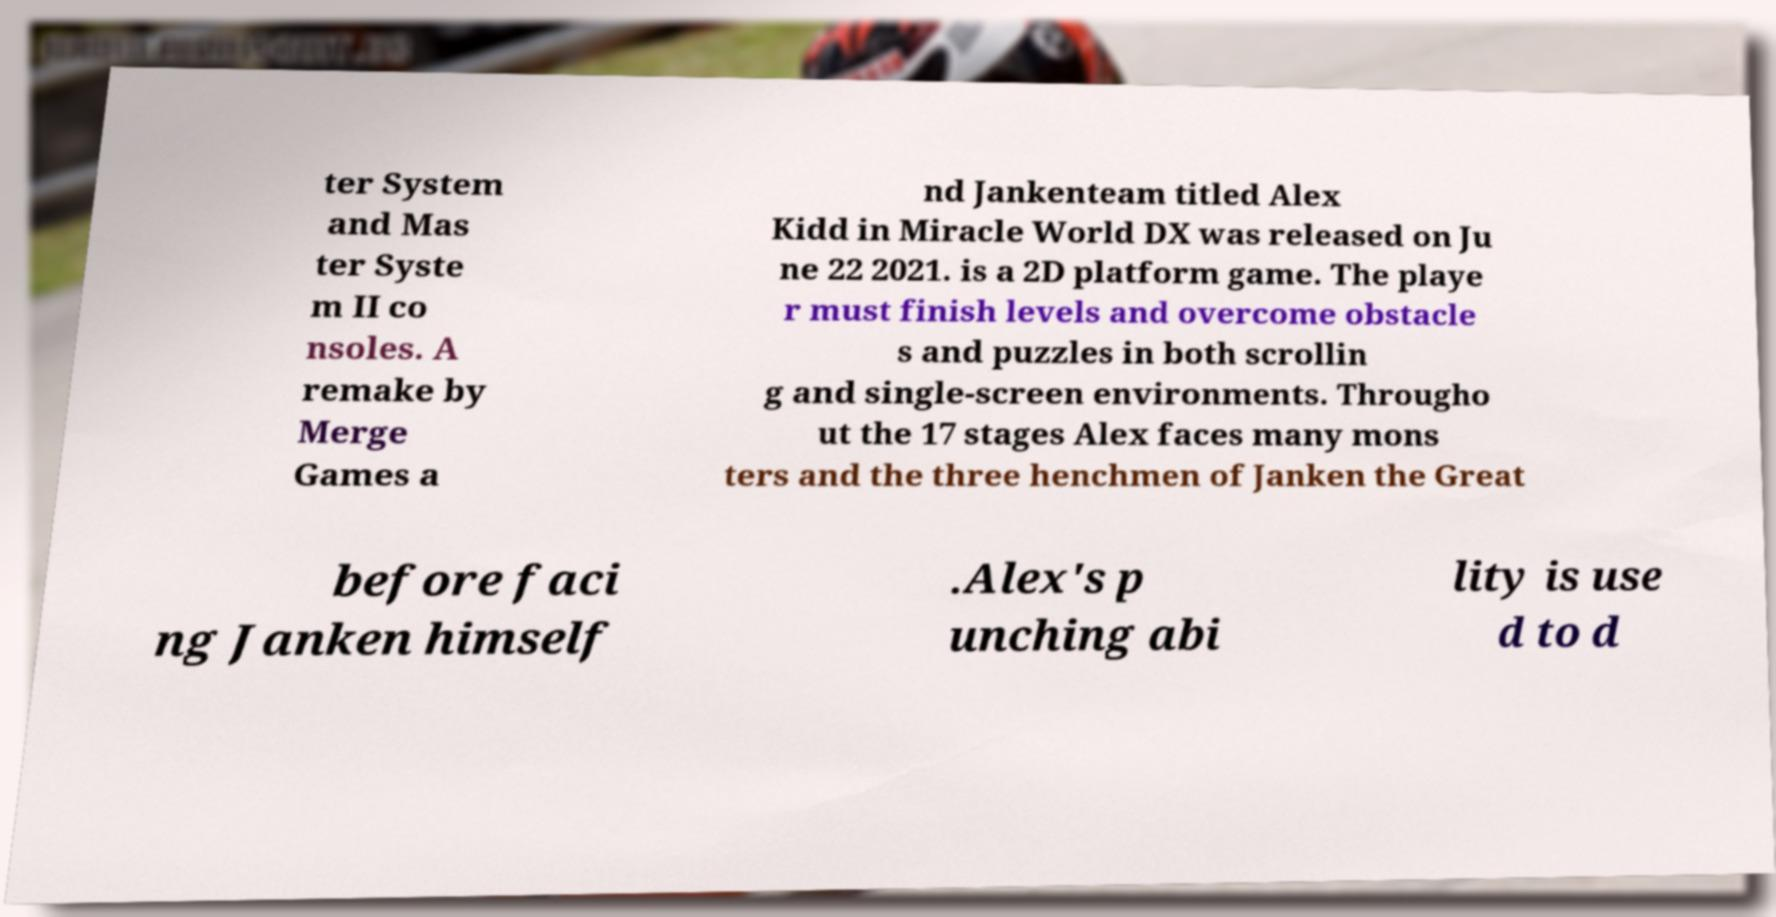For documentation purposes, I need the text within this image transcribed. Could you provide that? ter System and Mas ter Syste m II co nsoles. A remake by Merge Games a nd Jankenteam titled Alex Kidd in Miracle World DX was released on Ju ne 22 2021. is a 2D platform game. The playe r must finish levels and overcome obstacle s and puzzles in both scrollin g and single-screen environments. Througho ut the 17 stages Alex faces many mons ters and the three henchmen of Janken the Great before faci ng Janken himself .Alex's p unching abi lity is use d to d 